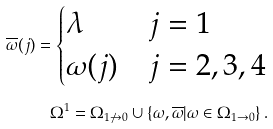Convert formula to latex. <formula><loc_0><loc_0><loc_500><loc_500>\overline { \omega } ( j ) = \begin{cases} \lambda & j = 1 \\ \omega ( j ) & j = 2 , 3 , 4 \end{cases} \\ \Omega ^ { 1 } = \Omega _ { 1 \not \to 0 } \cup \{ \omega , \overline { \omega } | \omega \in \Omega _ { 1 \to 0 } \} \, .</formula> 